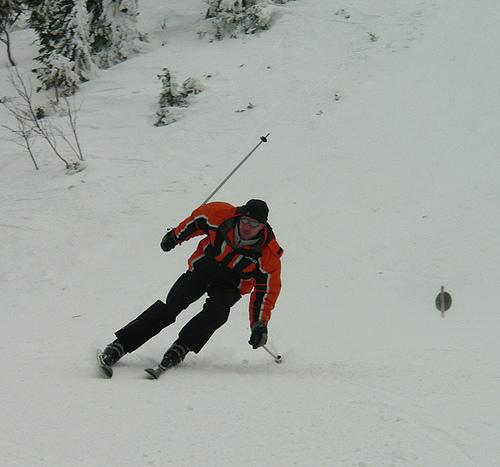Is this man going too fast downhill?
Answer briefly. No. What is this person wearing on their head?
Answer briefly. Hat. Is a sled pictured in the scene?
Be succinct. No. Is the man in a straight up position?
Write a very short answer. No. Is this man athletic?
Give a very brief answer. Yes. Is he taking a rest?
Answer briefly. No. What gender is the skier?
Write a very short answer. Male. Do you see snow tracks?
Answer briefly. No. Is this a good photo op?
Short answer required. Yes. What is the man riding on?
Write a very short answer. Skis. 